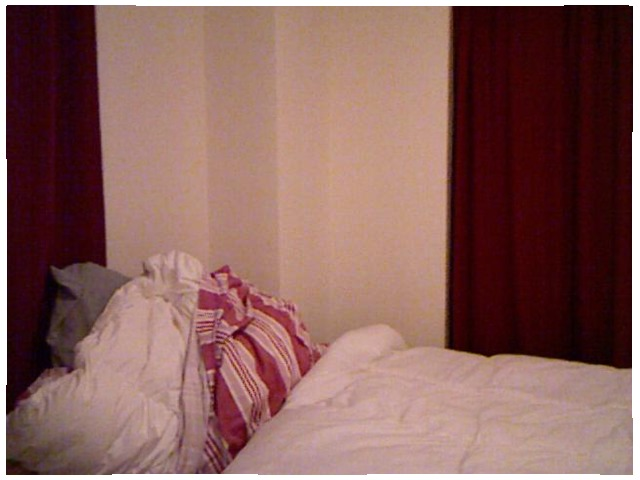<image>
Is there a wall to the right of the bedsheet? Yes. From this viewpoint, the wall is positioned to the right side relative to the bedsheet. 